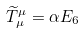<formula> <loc_0><loc_0><loc_500><loc_500>\widetilde { T } _ { \mu } ^ { \mu } = \alpha E _ { 6 }</formula> 